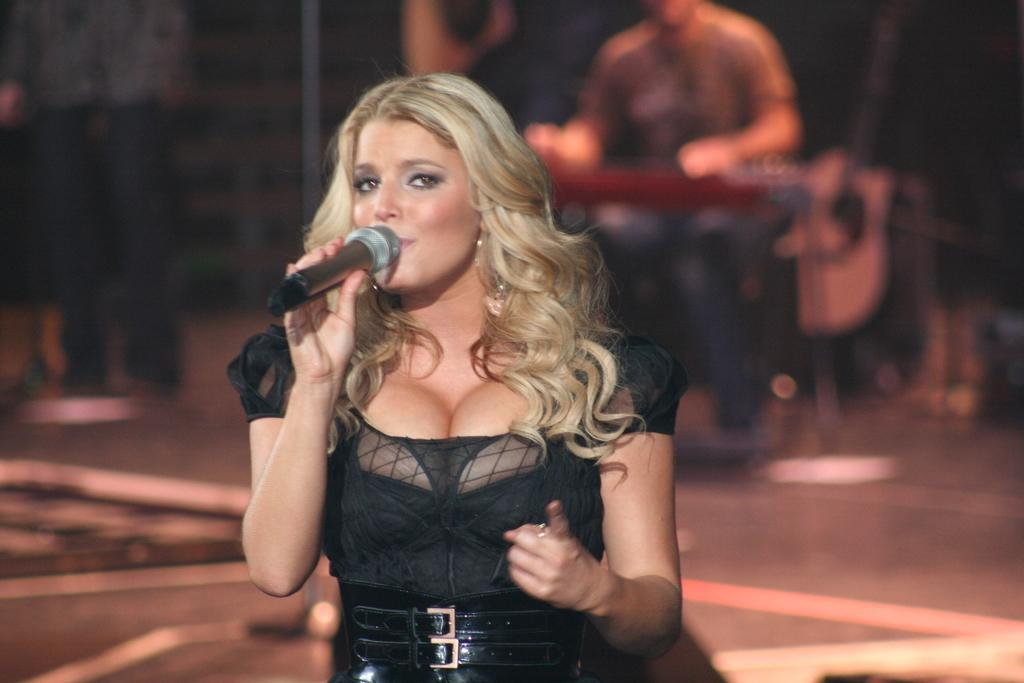Who is the main subject in the image? There is a woman in the image. What is the woman wearing? The woman is wearing a black dress. What is the woman doing in the image? The woman is singing. What object is in front of the woman? There is a microphone in front of the woman. Can you describe the man in the image? There is a man sitting on a chair in the image. What musical instrument is present in the image? There is a guitar in the image. What type of horse can be seen pulling a plough in the image? There is no horse or plough present in the image. How does the man fold the guitar in the image? There is no folding of the guitar in the image; the guitar is not depicted as being folded. 